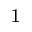Convert formula to latex. <formula><loc_0><loc_0><loc_500><loc_500>^ { 1 }</formula> 